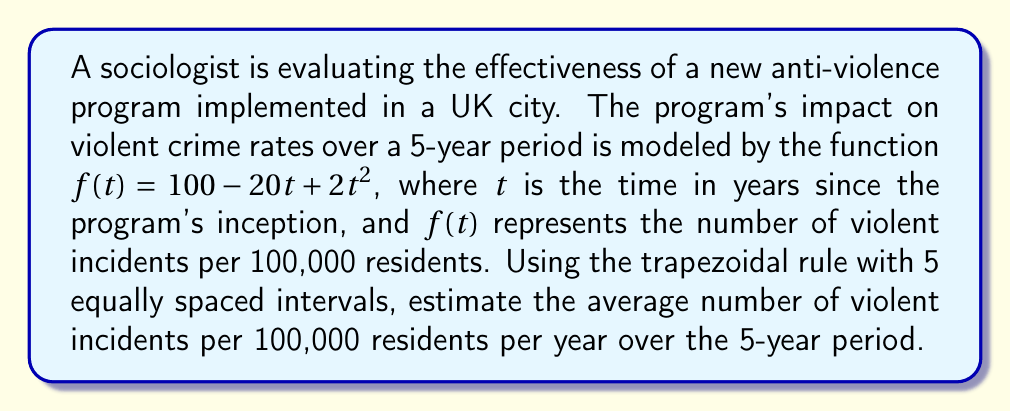Teach me how to tackle this problem. To solve this problem, we'll use the trapezoidal rule for numerical integration:

1) The trapezoidal rule is given by:
   $$\int_{a}^{b} f(x) dx \approx \frac{h}{2}[f(x_0) + 2f(x_1) + 2f(x_2) + ... + 2f(x_{n-1}) + f(x_n)]$$
   where $h = \frac{b-a}{n}$, and $n$ is the number of intervals.

2) In our case, $a=0$, $b=5$, and $n=5$. So $h = \frac{5-0}{5} = 1$.

3) We need to calculate $f(t)$ for $t = 0, 1, 2, 3, 4, 5$:
   $f(0) = 100 - 20(0) + 2(0)^2 = 100$
   $f(1) = 100 - 20(1) + 2(1)^2 = 82$
   $f(2) = 100 - 20(2) + 2(2)^2 = 68$
   $f(3) = 100 - 20(3) + 2(3)^2 = 58$
   $f(4) = 100 - 20(4) + 2(4)^2 = 52$
   $f(5) = 100 - 20(5) + 2(5)^2 = 50$

4) Applying the trapezoidal rule:
   $$\int_{0}^{5} f(t) dt \approx \frac{1}{2}[100 + 2(82) + 2(68) + 2(58) + 2(52) + 50]$$
   $$= \frac{1}{2}[100 + 164 + 136 + 116 + 104 + 50]$$
   $$= \frac{1}{2}[670] = 335$$

5) This gives us the total number of violent incidents per 100,000 residents over 5 years.

6) To get the average per year, we divide by 5:
   $$\text{Average per year} = \frac{335}{5} = 67$$

Therefore, the average number of violent incidents per 100,000 residents per year over the 5-year period is approximately 67.
Answer: 67 incidents per 100,000 residents per year 